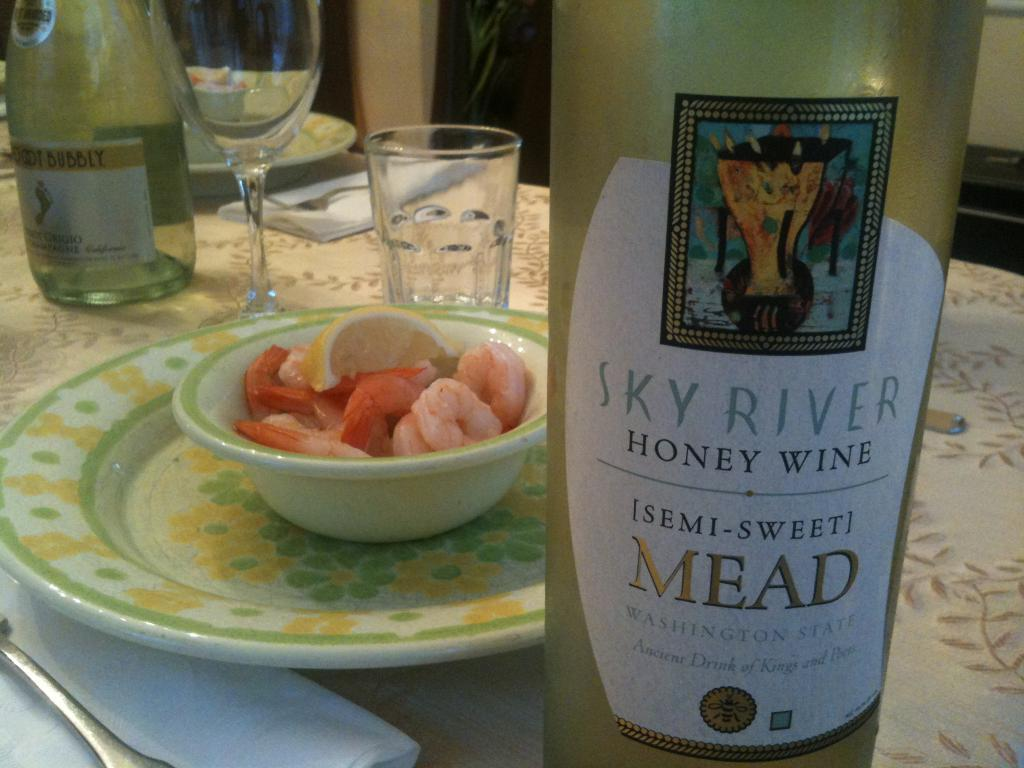<image>
Write a terse but informative summary of the picture. Shrimp cocktail in a bowl is in between Chardonnay and Sky River honey wine. 